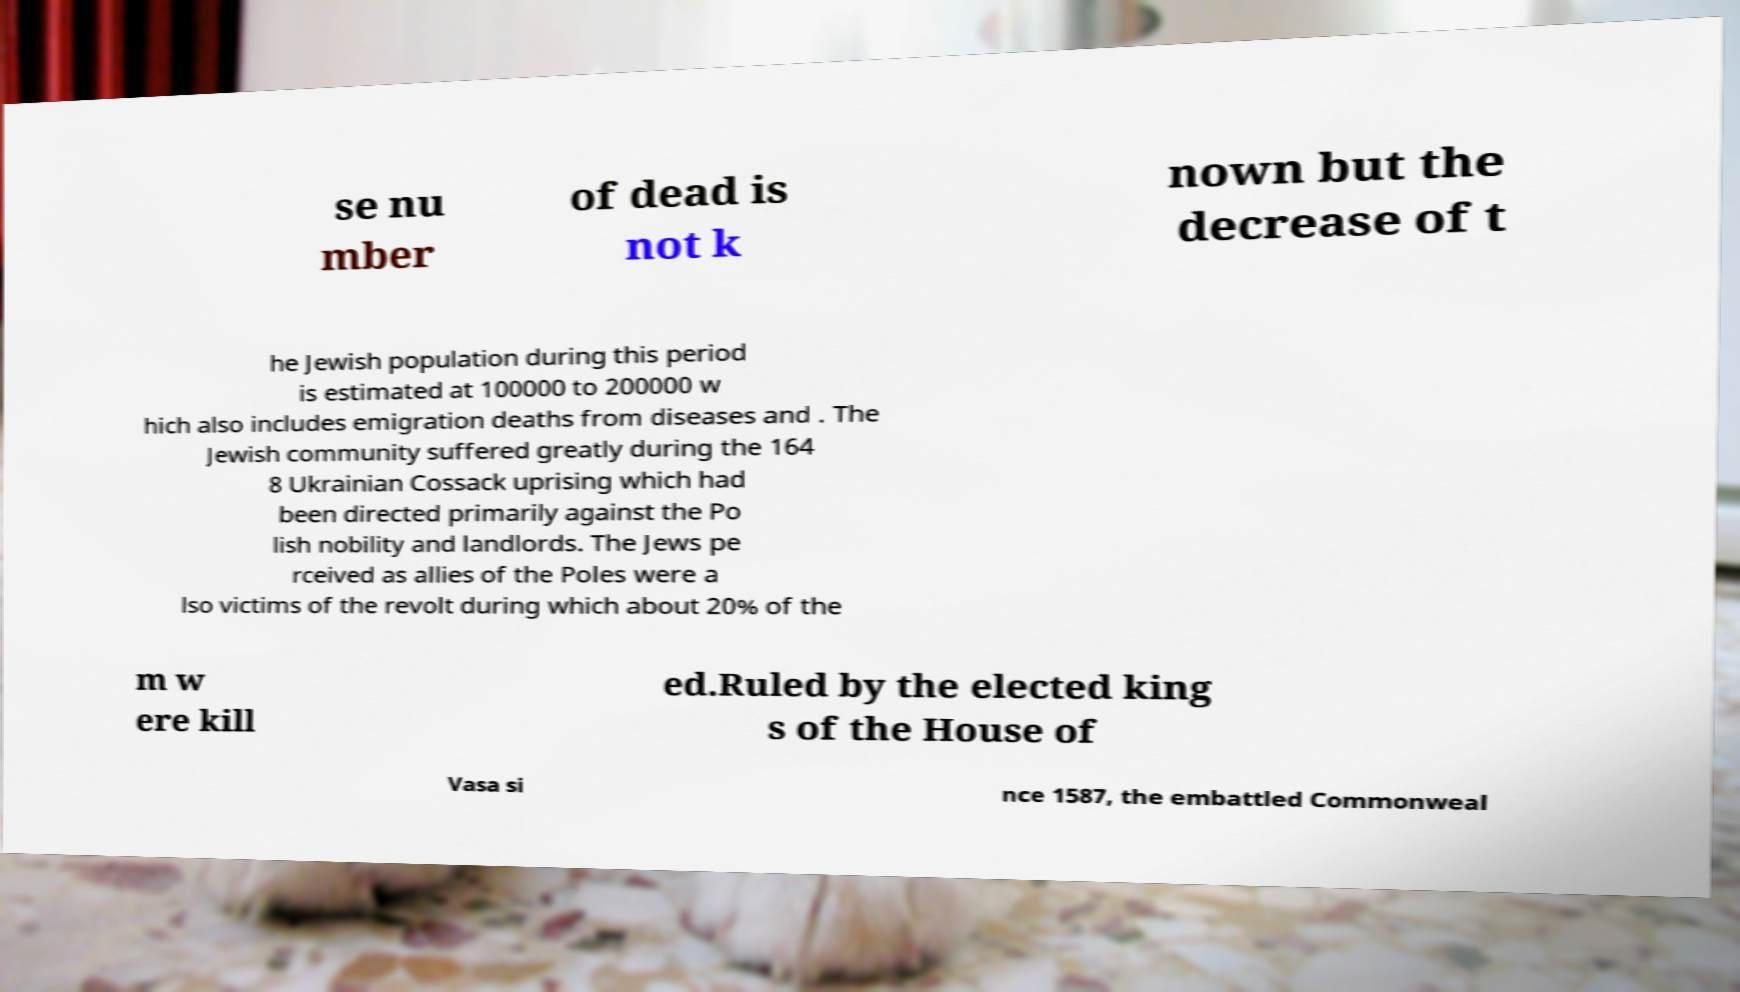For documentation purposes, I need the text within this image transcribed. Could you provide that? se nu mber of dead is not k nown but the decrease of t he Jewish population during this period is estimated at 100000 to 200000 w hich also includes emigration deaths from diseases and . The Jewish community suffered greatly during the 164 8 Ukrainian Cossack uprising which had been directed primarily against the Po lish nobility and landlords. The Jews pe rceived as allies of the Poles were a lso victims of the revolt during which about 20% of the m w ere kill ed.Ruled by the elected king s of the House of Vasa si nce 1587, the embattled Commonweal 